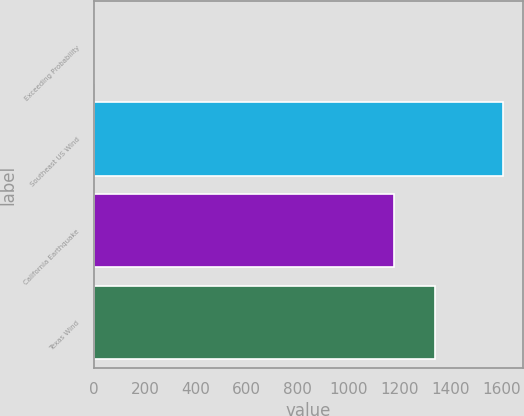Convert chart to OTSL. <chart><loc_0><loc_0><loc_500><loc_500><bar_chart><fcel>Exceeding Probability<fcel>Southeast US Wind<fcel>California Earthquake<fcel>Texas Wind<nl><fcel>0.2<fcel>1605<fcel>1177<fcel>1337.48<nl></chart> 